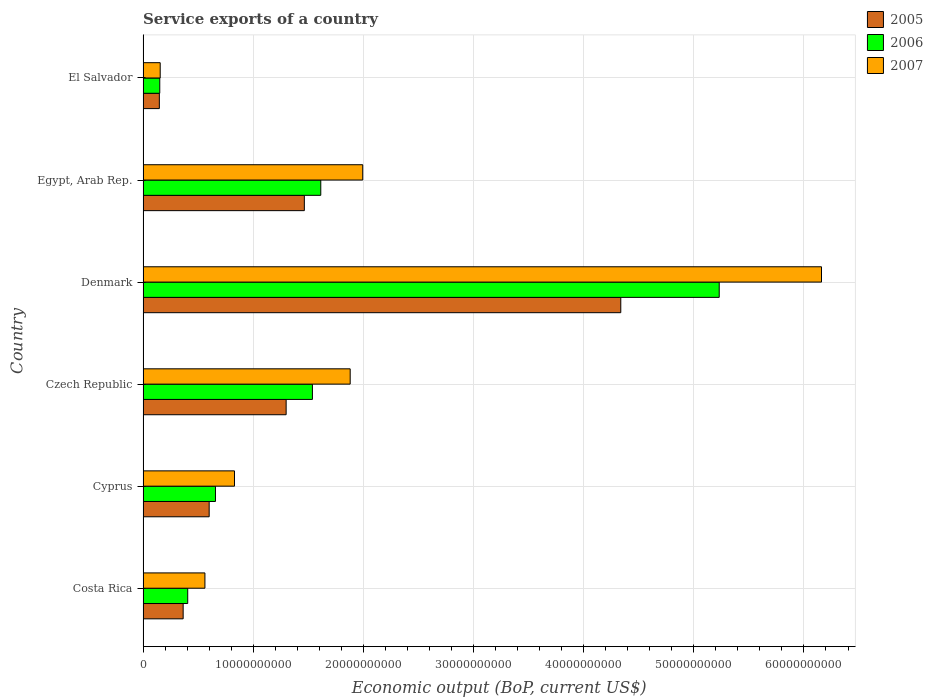How many different coloured bars are there?
Make the answer very short. 3. Are the number of bars per tick equal to the number of legend labels?
Keep it short and to the point. Yes. How many bars are there on the 2nd tick from the top?
Provide a short and direct response. 3. How many bars are there on the 5th tick from the bottom?
Give a very brief answer. 3. In how many cases, is the number of bars for a given country not equal to the number of legend labels?
Give a very brief answer. 0. What is the service exports in 2005 in Denmark?
Offer a terse response. 4.34e+1. Across all countries, what is the maximum service exports in 2005?
Ensure brevity in your answer.  4.34e+1. Across all countries, what is the minimum service exports in 2005?
Give a very brief answer. 1.48e+09. In which country was the service exports in 2006 maximum?
Give a very brief answer. Denmark. In which country was the service exports in 2006 minimum?
Your answer should be compact. El Salvador. What is the total service exports in 2007 in the graph?
Make the answer very short. 1.16e+11. What is the difference between the service exports in 2005 in Cyprus and that in El Salvador?
Offer a terse response. 4.52e+09. What is the difference between the service exports in 2005 in Czech Republic and the service exports in 2007 in Egypt, Arab Rep.?
Your answer should be compact. -6.95e+09. What is the average service exports in 2006 per country?
Provide a short and direct response. 1.60e+1. What is the difference between the service exports in 2005 and service exports in 2006 in Costa Rica?
Your response must be concise. -4.14e+08. What is the ratio of the service exports in 2006 in Costa Rica to that in Cyprus?
Offer a very short reply. 0.62. Is the difference between the service exports in 2005 in Costa Rica and El Salvador greater than the difference between the service exports in 2006 in Costa Rica and El Salvador?
Your response must be concise. No. What is the difference between the highest and the second highest service exports in 2005?
Give a very brief answer. 2.87e+1. What is the difference between the highest and the lowest service exports in 2005?
Your answer should be very brief. 4.19e+1. In how many countries, is the service exports in 2005 greater than the average service exports in 2005 taken over all countries?
Give a very brief answer. 2. Is the sum of the service exports in 2006 in Cyprus and Denmark greater than the maximum service exports in 2007 across all countries?
Your response must be concise. No. What does the 1st bar from the top in Czech Republic represents?
Provide a succinct answer. 2007. What does the 2nd bar from the bottom in El Salvador represents?
Give a very brief answer. 2006. Is it the case that in every country, the sum of the service exports in 2007 and service exports in 2006 is greater than the service exports in 2005?
Ensure brevity in your answer.  Yes. What is the difference between two consecutive major ticks on the X-axis?
Give a very brief answer. 1.00e+1. Does the graph contain any zero values?
Ensure brevity in your answer.  No. Where does the legend appear in the graph?
Your answer should be very brief. Top right. How many legend labels are there?
Provide a short and direct response. 3. What is the title of the graph?
Offer a very short reply. Service exports of a country. What is the label or title of the X-axis?
Your answer should be very brief. Economic output (BoP, current US$). What is the label or title of the Y-axis?
Ensure brevity in your answer.  Country. What is the Economic output (BoP, current US$) in 2005 in Costa Rica?
Make the answer very short. 3.64e+09. What is the Economic output (BoP, current US$) of 2006 in Costa Rica?
Your response must be concise. 4.05e+09. What is the Economic output (BoP, current US$) in 2007 in Costa Rica?
Provide a short and direct response. 5.62e+09. What is the Economic output (BoP, current US$) of 2005 in Cyprus?
Make the answer very short. 6.00e+09. What is the Economic output (BoP, current US$) in 2006 in Cyprus?
Offer a terse response. 6.57e+09. What is the Economic output (BoP, current US$) of 2007 in Cyprus?
Make the answer very short. 8.30e+09. What is the Economic output (BoP, current US$) in 2005 in Czech Republic?
Your answer should be very brief. 1.30e+1. What is the Economic output (BoP, current US$) of 2006 in Czech Republic?
Your answer should be compact. 1.54e+1. What is the Economic output (BoP, current US$) of 2007 in Czech Republic?
Ensure brevity in your answer.  1.88e+1. What is the Economic output (BoP, current US$) of 2005 in Denmark?
Your answer should be compact. 4.34e+1. What is the Economic output (BoP, current US$) of 2006 in Denmark?
Your response must be concise. 5.23e+1. What is the Economic output (BoP, current US$) of 2007 in Denmark?
Make the answer very short. 6.16e+1. What is the Economic output (BoP, current US$) of 2005 in Egypt, Arab Rep.?
Your response must be concise. 1.46e+1. What is the Economic output (BoP, current US$) of 2006 in Egypt, Arab Rep.?
Your answer should be compact. 1.61e+1. What is the Economic output (BoP, current US$) of 2007 in Egypt, Arab Rep.?
Your answer should be compact. 1.99e+1. What is the Economic output (BoP, current US$) in 2005 in El Salvador?
Your answer should be compact. 1.48e+09. What is the Economic output (BoP, current US$) of 2006 in El Salvador?
Make the answer very short. 1.52e+09. What is the Economic output (BoP, current US$) of 2007 in El Salvador?
Ensure brevity in your answer.  1.56e+09. Across all countries, what is the maximum Economic output (BoP, current US$) in 2005?
Make the answer very short. 4.34e+1. Across all countries, what is the maximum Economic output (BoP, current US$) of 2006?
Give a very brief answer. 5.23e+1. Across all countries, what is the maximum Economic output (BoP, current US$) in 2007?
Keep it short and to the point. 6.16e+1. Across all countries, what is the minimum Economic output (BoP, current US$) in 2005?
Offer a very short reply. 1.48e+09. Across all countries, what is the minimum Economic output (BoP, current US$) of 2006?
Make the answer very short. 1.52e+09. Across all countries, what is the minimum Economic output (BoP, current US$) of 2007?
Offer a terse response. 1.56e+09. What is the total Economic output (BoP, current US$) of 2005 in the graph?
Make the answer very short. 8.21e+1. What is the total Economic output (BoP, current US$) of 2006 in the graph?
Ensure brevity in your answer.  9.60e+1. What is the total Economic output (BoP, current US$) of 2007 in the graph?
Give a very brief answer. 1.16e+11. What is the difference between the Economic output (BoP, current US$) in 2005 in Costa Rica and that in Cyprus?
Your response must be concise. -2.36e+09. What is the difference between the Economic output (BoP, current US$) in 2006 in Costa Rica and that in Cyprus?
Your answer should be very brief. -2.52e+09. What is the difference between the Economic output (BoP, current US$) in 2007 in Costa Rica and that in Cyprus?
Your response must be concise. -2.68e+09. What is the difference between the Economic output (BoP, current US$) of 2005 in Costa Rica and that in Czech Republic?
Provide a succinct answer. -9.35e+09. What is the difference between the Economic output (BoP, current US$) in 2006 in Costa Rica and that in Czech Republic?
Ensure brevity in your answer.  -1.13e+1. What is the difference between the Economic output (BoP, current US$) of 2007 in Costa Rica and that in Czech Republic?
Offer a terse response. -1.32e+1. What is the difference between the Economic output (BoP, current US$) of 2005 in Costa Rica and that in Denmark?
Your answer should be compact. -3.97e+1. What is the difference between the Economic output (BoP, current US$) in 2006 in Costa Rica and that in Denmark?
Ensure brevity in your answer.  -4.83e+1. What is the difference between the Economic output (BoP, current US$) of 2007 in Costa Rica and that in Denmark?
Ensure brevity in your answer.  -5.60e+1. What is the difference between the Economic output (BoP, current US$) of 2005 in Costa Rica and that in Egypt, Arab Rep.?
Make the answer very short. -1.10e+1. What is the difference between the Economic output (BoP, current US$) of 2006 in Costa Rica and that in Egypt, Arab Rep.?
Your answer should be compact. -1.21e+1. What is the difference between the Economic output (BoP, current US$) of 2007 in Costa Rica and that in Egypt, Arab Rep.?
Provide a short and direct response. -1.43e+1. What is the difference between the Economic output (BoP, current US$) of 2005 in Costa Rica and that in El Salvador?
Offer a very short reply. 2.16e+09. What is the difference between the Economic output (BoP, current US$) of 2006 in Costa Rica and that in El Salvador?
Keep it short and to the point. 2.54e+09. What is the difference between the Economic output (BoP, current US$) in 2007 in Costa Rica and that in El Salvador?
Give a very brief answer. 4.06e+09. What is the difference between the Economic output (BoP, current US$) of 2005 in Cyprus and that in Czech Republic?
Ensure brevity in your answer.  -6.99e+09. What is the difference between the Economic output (BoP, current US$) in 2006 in Cyprus and that in Czech Republic?
Ensure brevity in your answer.  -8.80e+09. What is the difference between the Economic output (BoP, current US$) of 2007 in Cyprus and that in Czech Republic?
Offer a terse response. -1.05e+1. What is the difference between the Economic output (BoP, current US$) of 2005 in Cyprus and that in Denmark?
Your answer should be compact. -3.74e+1. What is the difference between the Economic output (BoP, current US$) of 2006 in Cyprus and that in Denmark?
Your answer should be compact. -4.57e+1. What is the difference between the Economic output (BoP, current US$) of 2007 in Cyprus and that in Denmark?
Provide a succinct answer. -5.33e+1. What is the difference between the Economic output (BoP, current US$) of 2005 in Cyprus and that in Egypt, Arab Rep.?
Make the answer very short. -8.64e+09. What is the difference between the Economic output (BoP, current US$) in 2006 in Cyprus and that in Egypt, Arab Rep.?
Give a very brief answer. -9.56e+09. What is the difference between the Economic output (BoP, current US$) in 2007 in Cyprus and that in Egypt, Arab Rep.?
Your answer should be compact. -1.16e+1. What is the difference between the Economic output (BoP, current US$) in 2005 in Cyprus and that in El Salvador?
Give a very brief answer. 4.52e+09. What is the difference between the Economic output (BoP, current US$) of 2006 in Cyprus and that in El Salvador?
Keep it short and to the point. 5.06e+09. What is the difference between the Economic output (BoP, current US$) in 2007 in Cyprus and that in El Salvador?
Offer a terse response. 6.74e+09. What is the difference between the Economic output (BoP, current US$) in 2005 in Czech Republic and that in Denmark?
Make the answer very short. -3.04e+1. What is the difference between the Economic output (BoP, current US$) of 2006 in Czech Republic and that in Denmark?
Make the answer very short. -3.69e+1. What is the difference between the Economic output (BoP, current US$) in 2007 in Czech Republic and that in Denmark?
Your answer should be very brief. -4.28e+1. What is the difference between the Economic output (BoP, current US$) of 2005 in Czech Republic and that in Egypt, Arab Rep.?
Ensure brevity in your answer.  -1.65e+09. What is the difference between the Economic output (BoP, current US$) in 2006 in Czech Republic and that in Egypt, Arab Rep.?
Your response must be concise. -7.59e+08. What is the difference between the Economic output (BoP, current US$) in 2007 in Czech Republic and that in Egypt, Arab Rep.?
Give a very brief answer. -1.14e+09. What is the difference between the Economic output (BoP, current US$) in 2005 in Czech Republic and that in El Salvador?
Offer a very short reply. 1.15e+1. What is the difference between the Economic output (BoP, current US$) in 2006 in Czech Republic and that in El Salvador?
Offer a very short reply. 1.39e+1. What is the difference between the Economic output (BoP, current US$) in 2007 in Czech Republic and that in El Salvador?
Give a very brief answer. 1.72e+1. What is the difference between the Economic output (BoP, current US$) of 2005 in Denmark and that in Egypt, Arab Rep.?
Ensure brevity in your answer.  2.87e+1. What is the difference between the Economic output (BoP, current US$) in 2006 in Denmark and that in Egypt, Arab Rep.?
Provide a succinct answer. 3.62e+1. What is the difference between the Economic output (BoP, current US$) in 2007 in Denmark and that in Egypt, Arab Rep.?
Keep it short and to the point. 4.17e+1. What is the difference between the Economic output (BoP, current US$) in 2005 in Denmark and that in El Salvador?
Keep it short and to the point. 4.19e+1. What is the difference between the Economic output (BoP, current US$) in 2006 in Denmark and that in El Salvador?
Give a very brief answer. 5.08e+1. What is the difference between the Economic output (BoP, current US$) in 2007 in Denmark and that in El Salvador?
Your response must be concise. 6.00e+1. What is the difference between the Economic output (BoP, current US$) in 2005 in Egypt, Arab Rep. and that in El Salvador?
Provide a short and direct response. 1.32e+1. What is the difference between the Economic output (BoP, current US$) in 2006 in Egypt, Arab Rep. and that in El Salvador?
Provide a short and direct response. 1.46e+1. What is the difference between the Economic output (BoP, current US$) of 2007 in Egypt, Arab Rep. and that in El Salvador?
Make the answer very short. 1.84e+1. What is the difference between the Economic output (BoP, current US$) in 2005 in Costa Rica and the Economic output (BoP, current US$) in 2006 in Cyprus?
Your answer should be compact. -2.93e+09. What is the difference between the Economic output (BoP, current US$) in 2005 in Costa Rica and the Economic output (BoP, current US$) in 2007 in Cyprus?
Your response must be concise. -4.66e+09. What is the difference between the Economic output (BoP, current US$) in 2006 in Costa Rica and the Economic output (BoP, current US$) in 2007 in Cyprus?
Your answer should be compact. -4.25e+09. What is the difference between the Economic output (BoP, current US$) in 2005 in Costa Rica and the Economic output (BoP, current US$) in 2006 in Czech Republic?
Your answer should be compact. -1.17e+1. What is the difference between the Economic output (BoP, current US$) in 2005 in Costa Rica and the Economic output (BoP, current US$) in 2007 in Czech Republic?
Offer a terse response. -1.52e+1. What is the difference between the Economic output (BoP, current US$) of 2006 in Costa Rica and the Economic output (BoP, current US$) of 2007 in Czech Republic?
Your answer should be very brief. -1.48e+1. What is the difference between the Economic output (BoP, current US$) in 2005 in Costa Rica and the Economic output (BoP, current US$) in 2006 in Denmark?
Your answer should be compact. -4.87e+1. What is the difference between the Economic output (BoP, current US$) of 2005 in Costa Rica and the Economic output (BoP, current US$) of 2007 in Denmark?
Your response must be concise. -5.80e+1. What is the difference between the Economic output (BoP, current US$) of 2006 in Costa Rica and the Economic output (BoP, current US$) of 2007 in Denmark?
Offer a very short reply. -5.75e+1. What is the difference between the Economic output (BoP, current US$) in 2005 in Costa Rica and the Economic output (BoP, current US$) in 2006 in Egypt, Arab Rep.?
Make the answer very short. -1.25e+1. What is the difference between the Economic output (BoP, current US$) in 2005 in Costa Rica and the Economic output (BoP, current US$) in 2007 in Egypt, Arab Rep.?
Offer a very short reply. -1.63e+1. What is the difference between the Economic output (BoP, current US$) of 2006 in Costa Rica and the Economic output (BoP, current US$) of 2007 in Egypt, Arab Rep.?
Your response must be concise. -1.59e+1. What is the difference between the Economic output (BoP, current US$) of 2005 in Costa Rica and the Economic output (BoP, current US$) of 2006 in El Salvador?
Provide a short and direct response. 2.12e+09. What is the difference between the Economic output (BoP, current US$) of 2005 in Costa Rica and the Economic output (BoP, current US$) of 2007 in El Salvador?
Provide a short and direct response. 2.08e+09. What is the difference between the Economic output (BoP, current US$) in 2006 in Costa Rica and the Economic output (BoP, current US$) in 2007 in El Salvador?
Your response must be concise. 2.50e+09. What is the difference between the Economic output (BoP, current US$) in 2005 in Cyprus and the Economic output (BoP, current US$) in 2006 in Czech Republic?
Your response must be concise. -9.37e+09. What is the difference between the Economic output (BoP, current US$) in 2005 in Cyprus and the Economic output (BoP, current US$) in 2007 in Czech Republic?
Provide a succinct answer. -1.28e+1. What is the difference between the Economic output (BoP, current US$) in 2006 in Cyprus and the Economic output (BoP, current US$) in 2007 in Czech Republic?
Make the answer very short. -1.22e+1. What is the difference between the Economic output (BoP, current US$) of 2005 in Cyprus and the Economic output (BoP, current US$) of 2006 in Denmark?
Offer a very short reply. -4.63e+1. What is the difference between the Economic output (BoP, current US$) in 2005 in Cyprus and the Economic output (BoP, current US$) in 2007 in Denmark?
Offer a terse response. -5.56e+1. What is the difference between the Economic output (BoP, current US$) of 2006 in Cyprus and the Economic output (BoP, current US$) of 2007 in Denmark?
Give a very brief answer. -5.50e+1. What is the difference between the Economic output (BoP, current US$) in 2005 in Cyprus and the Economic output (BoP, current US$) in 2006 in Egypt, Arab Rep.?
Offer a terse response. -1.01e+1. What is the difference between the Economic output (BoP, current US$) in 2005 in Cyprus and the Economic output (BoP, current US$) in 2007 in Egypt, Arab Rep.?
Offer a terse response. -1.39e+1. What is the difference between the Economic output (BoP, current US$) of 2006 in Cyprus and the Economic output (BoP, current US$) of 2007 in Egypt, Arab Rep.?
Offer a terse response. -1.34e+1. What is the difference between the Economic output (BoP, current US$) in 2005 in Cyprus and the Economic output (BoP, current US$) in 2006 in El Salvador?
Keep it short and to the point. 4.49e+09. What is the difference between the Economic output (BoP, current US$) of 2005 in Cyprus and the Economic output (BoP, current US$) of 2007 in El Salvador?
Offer a very short reply. 4.45e+09. What is the difference between the Economic output (BoP, current US$) in 2006 in Cyprus and the Economic output (BoP, current US$) in 2007 in El Salvador?
Ensure brevity in your answer.  5.02e+09. What is the difference between the Economic output (BoP, current US$) in 2005 in Czech Republic and the Economic output (BoP, current US$) in 2006 in Denmark?
Provide a short and direct response. -3.93e+1. What is the difference between the Economic output (BoP, current US$) of 2005 in Czech Republic and the Economic output (BoP, current US$) of 2007 in Denmark?
Keep it short and to the point. -4.86e+1. What is the difference between the Economic output (BoP, current US$) of 2006 in Czech Republic and the Economic output (BoP, current US$) of 2007 in Denmark?
Give a very brief answer. -4.62e+1. What is the difference between the Economic output (BoP, current US$) in 2005 in Czech Republic and the Economic output (BoP, current US$) in 2006 in Egypt, Arab Rep.?
Offer a terse response. -3.14e+09. What is the difference between the Economic output (BoP, current US$) in 2005 in Czech Republic and the Economic output (BoP, current US$) in 2007 in Egypt, Arab Rep.?
Your response must be concise. -6.95e+09. What is the difference between the Economic output (BoP, current US$) of 2006 in Czech Republic and the Economic output (BoP, current US$) of 2007 in Egypt, Arab Rep.?
Provide a short and direct response. -4.57e+09. What is the difference between the Economic output (BoP, current US$) of 2005 in Czech Republic and the Economic output (BoP, current US$) of 2006 in El Salvador?
Provide a succinct answer. 1.15e+1. What is the difference between the Economic output (BoP, current US$) of 2005 in Czech Republic and the Economic output (BoP, current US$) of 2007 in El Salvador?
Your answer should be compact. 1.14e+1. What is the difference between the Economic output (BoP, current US$) in 2006 in Czech Republic and the Economic output (BoP, current US$) in 2007 in El Salvador?
Make the answer very short. 1.38e+1. What is the difference between the Economic output (BoP, current US$) of 2005 in Denmark and the Economic output (BoP, current US$) of 2006 in Egypt, Arab Rep.?
Offer a very short reply. 2.72e+1. What is the difference between the Economic output (BoP, current US$) of 2005 in Denmark and the Economic output (BoP, current US$) of 2007 in Egypt, Arab Rep.?
Provide a succinct answer. 2.34e+1. What is the difference between the Economic output (BoP, current US$) in 2006 in Denmark and the Economic output (BoP, current US$) in 2007 in Egypt, Arab Rep.?
Ensure brevity in your answer.  3.24e+1. What is the difference between the Economic output (BoP, current US$) in 2005 in Denmark and the Economic output (BoP, current US$) in 2006 in El Salvador?
Keep it short and to the point. 4.19e+1. What is the difference between the Economic output (BoP, current US$) in 2005 in Denmark and the Economic output (BoP, current US$) in 2007 in El Salvador?
Ensure brevity in your answer.  4.18e+1. What is the difference between the Economic output (BoP, current US$) of 2006 in Denmark and the Economic output (BoP, current US$) of 2007 in El Salvador?
Provide a short and direct response. 5.08e+1. What is the difference between the Economic output (BoP, current US$) of 2005 in Egypt, Arab Rep. and the Economic output (BoP, current US$) of 2006 in El Salvador?
Provide a succinct answer. 1.31e+1. What is the difference between the Economic output (BoP, current US$) in 2005 in Egypt, Arab Rep. and the Economic output (BoP, current US$) in 2007 in El Salvador?
Your answer should be very brief. 1.31e+1. What is the difference between the Economic output (BoP, current US$) in 2006 in Egypt, Arab Rep. and the Economic output (BoP, current US$) in 2007 in El Salvador?
Provide a short and direct response. 1.46e+1. What is the average Economic output (BoP, current US$) in 2005 per country?
Offer a very short reply. 1.37e+1. What is the average Economic output (BoP, current US$) in 2006 per country?
Offer a very short reply. 1.60e+1. What is the average Economic output (BoP, current US$) in 2007 per country?
Keep it short and to the point. 1.93e+1. What is the difference between the Economic output (BoP, current US$) of 2005 and Economic output (BoP, current US$) of 2006 in Costa Rica?
Ensure brevity in your answer.  -4.14e+08. What is the difference between the Economic output (BoP, current US$) in 2005 and Economic output (BoP, current US$) in 2007 in Costa Rica?
Your answer should be compact. -1.98e+09. What is the difference between the Economic output (BoP, current US$) in 2006 and Economic output (BoP, current US$) in 2007 in Costa Rica?
Provide a short and direct response. -1.56e+09. What is the difference between the Economic output (BoP, current US$) in 2005 and Economic output (BoP, current US$) in 2006 in Cyprus?
Provide a short and direct response. -5.72e+08. What is the difference between the Economic output (BoP, current US$) of 2005 and Economic output (BoP, current US$) of 2007 in Cyprus?
Your response must be concise. -2.30e+09. What is the difference between the Economic output (BoP, current US$) of 2006 and Economic output (BoP, current US$) of 2007 in Cyprus?
Ensure brevity in your answer.  -1.73e+09. What is the difference between the Economic output (BoP, current US$) in 2005 and Economic output (BoP, current US$) in 2006 in Czech Republic?
Your answer should be very brief. -2.39e+09. What is the difference between the Economic output (BoP, current US$) in 2005 and Economic output (BoP, current US$) in 2007 in Czech Republic?
Give a very brief answer. -5.82e+09. What is the difference between the Economic output (BoP, current US$) in 2006 and Economic output (BoP, current US$) in 2007 in Czech Republic?
Give a very brief answer. -3.43e+09. What is the difference between the Economic output (BoP, current US$) in 2005 and Economic output (BoP, current US$) in 2006 in Denmark?
Ensure brevity in your answer.  -8.94e+09. What is the difference between the Economic output (BoP, current US$) in 2005 and Economic output (BoP, current US$) in 2007 in Denmark?
Offer a very short reply. -1.82e+1. What is the difference between the Economic output (BoP, current US$) of 2006 and Economic output (BoP, current US$) of 2007 in Denmark?
Offer a terse response. -9.29e+09. What is the difference between the Economic output (BoP, current US$) of 2005 and Economic output (BoP, current US$) of 2006 in Egypt, Arab Rep.?
Offer a terse response. -1.49e+09. What is the difference between the Economic output (BoP, current US$) of 2005 and Economic output (BoP, current US$) of 2007 in Egypt, Arab Rep.?
Provide a short and direct response. -5.30e+09. What is the difference between the Economic output (BoP, current US$) in 2006 and Economic output (BoP, current US$) in 2007 in Egypt, Arab Rep.?
Your response must be concise. -3.81e+09. What is the difference between the Economic output (BoP, current US$) in 2005 and Economic output (BoP, current US$) in 2006 in El Salvador?
Ensure brevity in your answer.  -3.79e+07. What is the difference between the Economic output (BoP, current US$) of 2005 and Economic output (BoP, current US$) of 2007 in El Salvador?
Your answer should be compact. -7.76e+07. What is the difference between the Economic output (BoP, current US$) in 2006 and Economic output (BoP, current US$) in 2007 in El Salvador?
Keep it short and to the point. -3.97e+07. What is the ratio of the Economic output (BoP, current US$) in 2005 in Costa Rica to that in Cyprus?
Ensure brevity in your answer.  0.61. What is the ratio of the Economic output (BoP, current US$) of 2006 in Costa Rica to that in Cyprus?
Your answer should be compact. 0.62. What is the ratio of the Economic output (BoP, current US$) of 2007 in Costa Rica to that in Cyprus?
Give a very brief answer. 0.68. What is the ratio of the Economic output (BoP, current US$) of 2005 in Costa Rica to that in Czech Republic?
Offer a terse response. 0.28. What is the ratio of the Economic output (BoP, current US$) in 2006 in Costa Rica to that in Czech Republic?
Make the answer very short. 0.26. What is the ratio of the Economic output (BoP, current US$) of 2007 in Costa Rica to that in Czech Republic?
Your response must be concise. 0.3. What is the ratio of the Economic output (BoP, current US$) in 2005 in Costa Rica to that in Denmark?
Offer a very short reply. 0.08. What is the ratio of the Economic output (BoP, current US$) of 2006 in Costa Rica to that in Denmark?
Offer a terse response. 0.08. What is the ratio of the Economic output (BoP, current US$) of 2007 in Costa Rica to that in Denmark?
Offer a terse response. 0.09. What is the ratio of the Economic output (BoP, current US$) of 2005 in Costa Rica to that in Egypt, Arab Rep.?
Make the answer very short. 0.25. What is the ratio of the Economic output (BoP, current US$) in 2006 in Costa Rica to that in Egypt, Arab Rep.?
Offer a terse response. 0.25. What is the ratio of the Economic output (BoP, current US$) of 2007 in Costa Rica to that in Egypt, Arab Rep.?
Keep it short and to the point. 0.28. What is the ratio of the Economic output (BoP, current US$) of 2005 in Costa Rica to that in El Salvador?
Provide a succinct answer. 2.46. What is the ratio of the Economic output (BoP, current US$) of 2006 in Costa Rica to that in El Salvador?
Provide a short and direct response. 2.67. What is the ratio of the Economic output (BoP, current US$) of 2007 in Costa Rica to that in El Salvador?
Your answer should be very brief. 3.61. What is the ratio of the Economic output (BoP, current US$) of 2005 in Cyprus to that in Czech Republic?
Keep it short and to the point. 0.46. What is the ratio of the Economic output (BoP, current US$) in 2006 in Cyprus to that in Czech Republic?
Ensure brevity in your answer.  0.43. What is the ratio of the Economic output (BoP, current US$) in 2007 in Cyprus to that in Czech Republic?
Offer a very short reply. 0.44. What is the ratio of the Economic output (BoP, current US$) of 2005 in Cyprus to that in Denmark?
Keep it short and to the point. 0.14. What is the ratio of the Economic output (BoP, current US$) in 2006 in Cyprus to that in Denmark?
Ensure brevity in your answer.  0.13. What is the ratio of the Economic output (BoP, current US$) of 2007 in Cyprus to that in Denmark?
Offer a very short reply. 0.13. What is the ratio of the Economic output (BoP, current US$) of 2005 in Cyprus to that in Egypt, Arab Rep.?
Offer a terse response. 0.41. What is the ratio of the Economic output (BoP, current US$) of 2006 in Cyprus to that in Egypt, Arab Rep.?
Give a very brief answer. 0.41. What is the ratio of the Economic output (BoP, current US$) in 2007 in Cyprus to that in Egypt, Arab Rep.?
Your answer should be very brief. 0.42. What is the ratio of the Economic output (BoP, current US$) in 2005 in Cyprus to that in El Salvador?
Make the answer very short. 4.06. What is the ratio of the Economic output (BoP, current US$) in 2006 in Cyprus to that in El Salvador?
Your answer should be compact. 4.34. What is the ratio of the Economic output (BoP, current US$) of 2007 in Cyprus to that in El Salvador?
Provide a succinct answer. 5.34. What is the ratio of the Economic output (BoP, current US$) in 2005 in Czech Republic to that in Denmark?
Provide a short and direct response. 0.3. What is the ratio of the Economic output (BoP, current US$) in 2006 in Czech Republic to that in Denmark?
Give a very brief answer. 0.29. What is the ratio of the Economic output (BoP, current US$) of 2007 in Czech Republic to that in Denmark?
Your response must be concise. 0.31. What is the ratio of the Economic output (BoP, current US$) of 2005 in Czech Republic to that in Egypt, Arab Rep.?
Your answer should be compact. 0.89. What is the ratio of the Economic output (BoP, current US$) of 2006 in Czech Republic to that in Egypt, Arab Rep.?
Make the answer very short. 0.95. What is the ratio of the Economic output (BoP, current US$) of 2007 in Czech Republic to that in Egypt, Arab Rep.?
Your answer should be very brief. 0.94. What is the ratio of the Economic output (BoP, current US$) in 2005 in Czech Republic to that in El Salvador?
Keep it short and to the point. 8.79. What is the ratio of the Economic output (BoP, current US$) of 2006 in Czech Republic to that in El Salvador?
Make the answer very short. 10.14. What is the ratio of the Economic output (BoP, current US$) in 2007 in Czech Republic to that in El Salvador?
Provide a succinct answer. 12.09. What is the ratio of the Economic output (BoP, current US$) of 2005 in Denmark to that in Egypt, Arab Rep.?
Give a very brief answer. 2.96. What is the ratio of the Economic output (BoP, current US$) in 2006 in Denmark to that in Egypt, Arab Rep.?
Give a very brief answer. 3.24. What is the ratio of the Economic output (BoP, current US$) in 2007 in Denmark to that in Egypt, Arab Rep.?
Provide a succinct answer. 3.09. What is the ratio of the Economic output (BoP, current US$) of 2005 in Denmark to that in El Salvador?
Make the answer very short. 29.34. What is the ratio of the Economic output (BoP, current US$) of 2006 in Denmark to that in El Salvador?
Your answer should be compact. 34.5. What is the ratio of the Economic output (BoP, current US$) of 2007 in Denmark to that in El Salvador?
Provide a succinct answer. 39.59. What is the ratio of the Economic output (BoP, current US$) of 2005 in Egypt, Arab Rep. to that in El Salvador?
Offer a very short reply. 9.91. What is the ratio of the Economic output (BoP, current US$) of 2006 in Egypt, Arab Rep. to that in El Salvador?
Your response must be concise. 10.64. What is the ratio of the Economic output (BoP, current US$) in 2007 in Egypt, Arab Rep. to that in El Salvador?
Provide a succinct answer. 12.82. What is the difference between the highest and the second highest Economic output (BoP, current US$) of 2005?
Make the answer very short. 2.87e+1. What is the difference between the highest and the second highest Economic output (BoP, current US$) in 2006?
Your answer should be compact. 3.62e+1. What is the difference between the highest and the second highest Economic output (BoP, current US$) of 2007?
Offer a very short reply. 4.17e+1. What is the difference between the highest and the lowest Economic output (BoP, current US$) in 2005?
Keep it short and to the point. 4.19e+1. What is the difference between the highest and the lowest Economic output (BoP, current US$) in 2006?
Your answer should be compact. 5.08e+1. What is the difference between the highest and the lowest Economic output (BoP, current US$) in 2007?
Make the answer very short. 6.00e+1. 